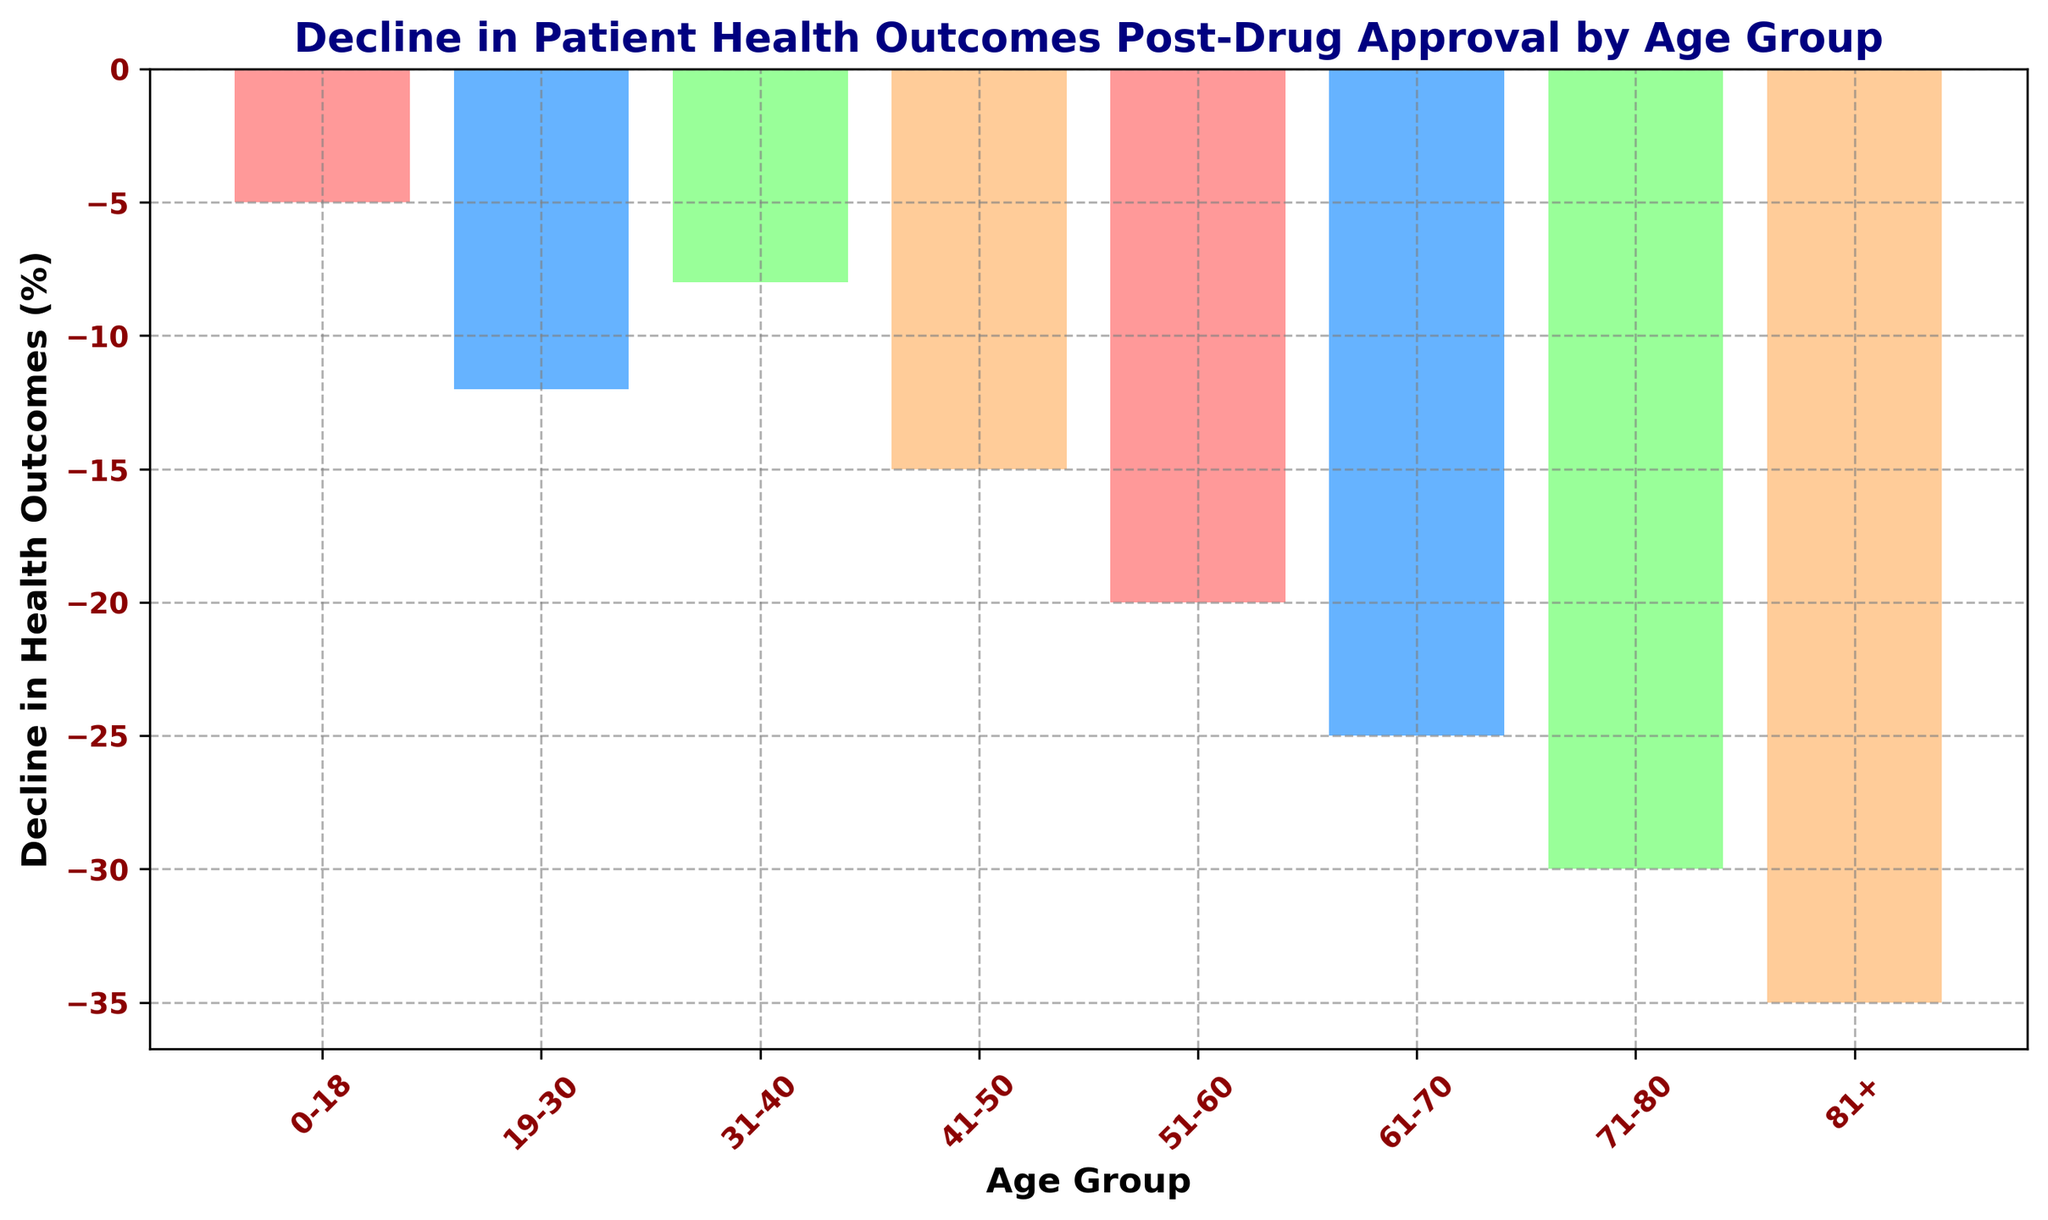What is the age group with the highest decline in health outcomes post-drug approval? The bar for the age group 81+ is the tallest and thus represents the highest decline in health outcomes.
Answer: 81+ Which age group has a decline in health outcomes of -20%? The bar corresponding to the 51-60 age group has a value of -20%.
Answer: 51-60 What is the difference in decline in health outcomes between the 0-18 and 81+ age groups? The 0-18 age group has a decline of -5%, and the 81+ age group has a decline of -35%, so the difference is -35% - (-5%) = -30%.
Answer: -30% Among the age groups 19-30 and 31-40, which one experienced a greater decline in health outcomes? The bar for the 19-30 age group is lower compared to the 31-40 age group. Specifically, the decline is -12% for 19-30 and -8% for 31-40, hence -12% < -8%.
Answer: 19-30 What is the average decline in health outcomes for the age groups 41-50 and 51-60? The 41-50 age group has a decline of -15% and the 51-60 age group has a decline of -20%. The average is (-15 + -20)/2 = -17.5%.
Answer: -17.5% Which age groups have declines in health outcomes greater than -20%? The bars corresponding to the 61-70, 71-80, and 81+ age groups all have declines greater than -20% (-25%, -30%, and -35% respectively).
Answer: 61-70, 71-80, 81+ By how much does the decline in health outcomes for the 31-40 age group surpass that of the 0-18 age group? The 31-40 age group has a decline of -8%, while the 0-18 age group has a decline of -5%. So, -8% - (-5%) = -3%.
Answer: -3% What's the total decline in health outcomes for all age groups combined? The total decline is the sum of all the negative values: -5% -12% -8% -15% -20% -25% -30% -35% = -150%.
Answer: -150% Identify the age group with the median decline in health outcomes. The data points in ascending order are -5%, -8%, -12%, -15%, -20%, -25%, -30%, and -35%. The median lies between the 4th and 5th values, which are -15% and -20%. The average of these two values is (-15% + -20%) / 2 = -17.5%. The age group closest to the median value is 51-60.
Answer: 51-60 